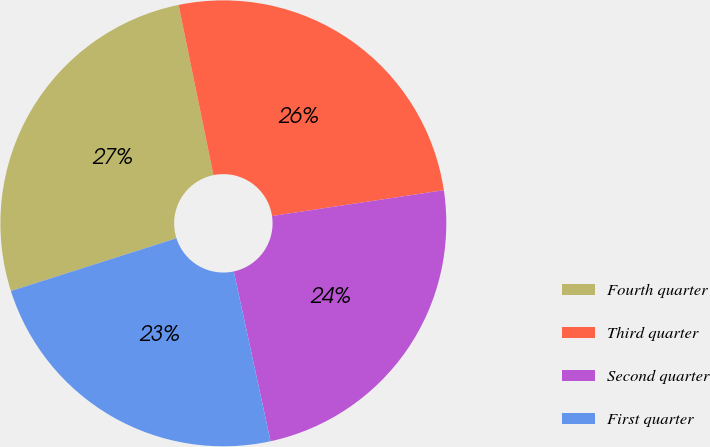Convert chart to OTSL. <chart><loc_0><loc_0><loc_500><loc_500><pie_chart><fcel>Fourth quarter<fcel>Third quarter<fcel>Second quarter<fcel>First quarter<nl><fcel>26.69%<fcel>25.85%<fcel>23.98%<fcel>23.49%<nl></chart> 